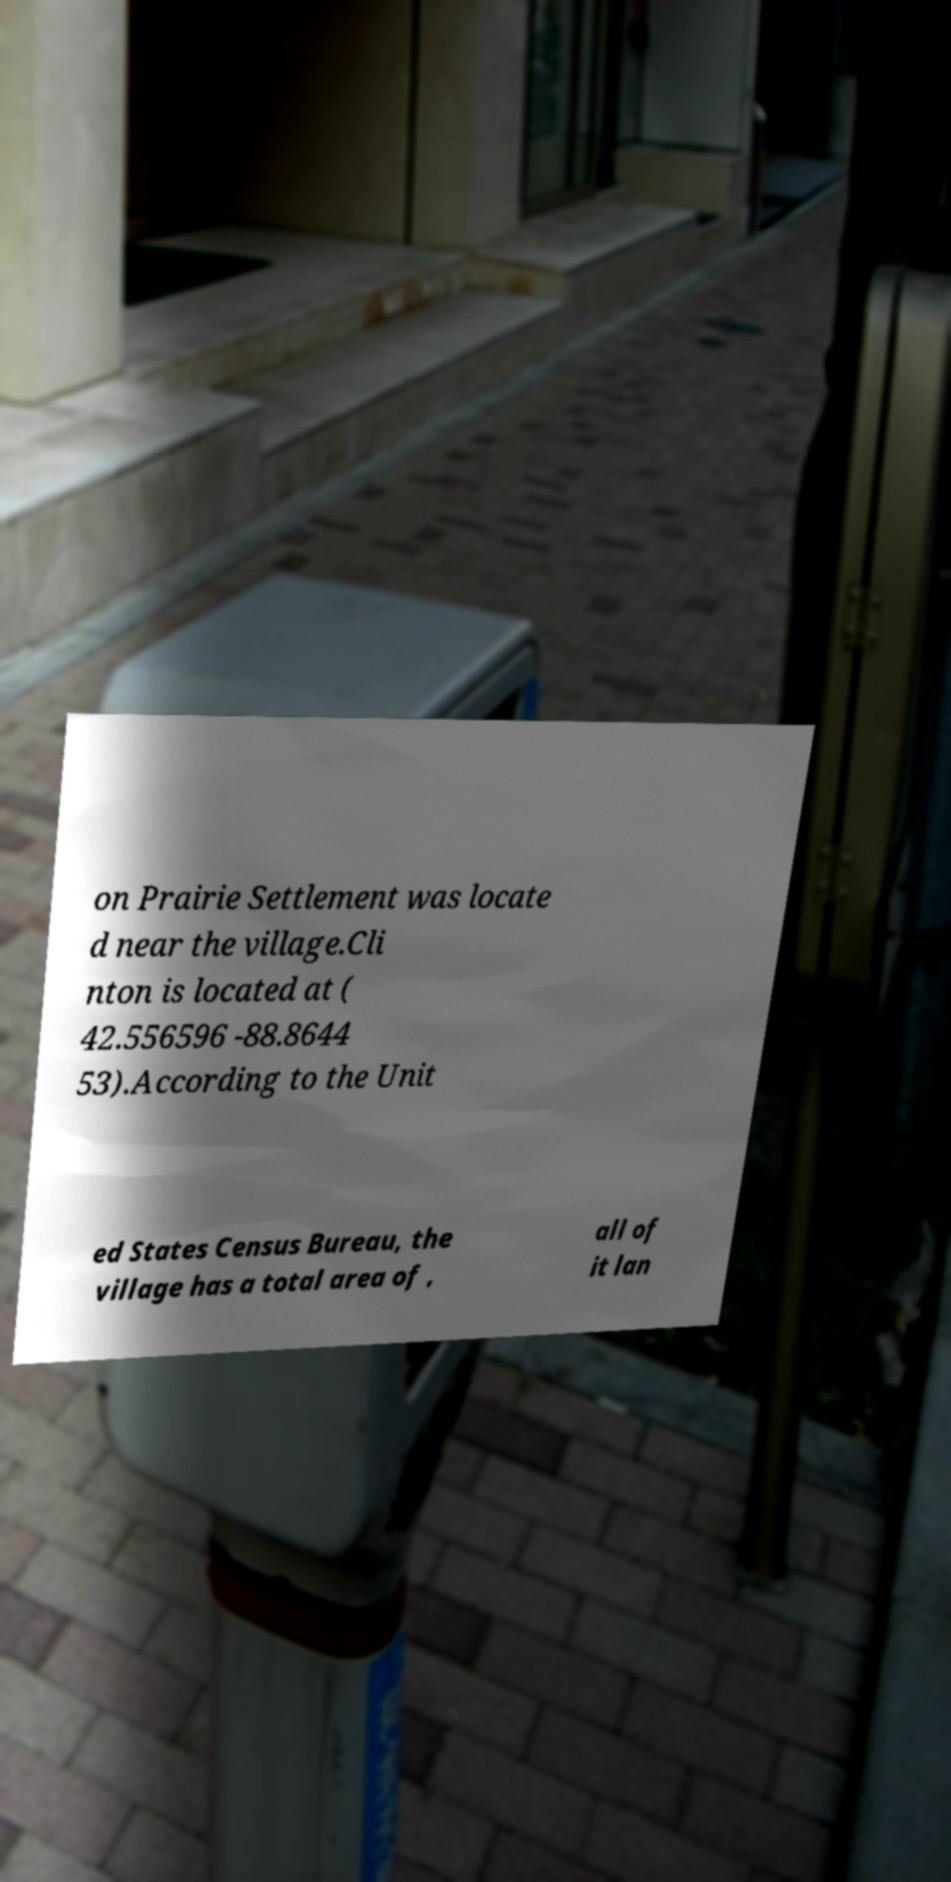Please identify and transcribe the text found in this image. on Prairie Settlement was locate d near the village.Cli nton is located at ( 42.556596 -88.8644 53).According to the Unit ed States Census Bureau, the village has a total area of , all of it lan 